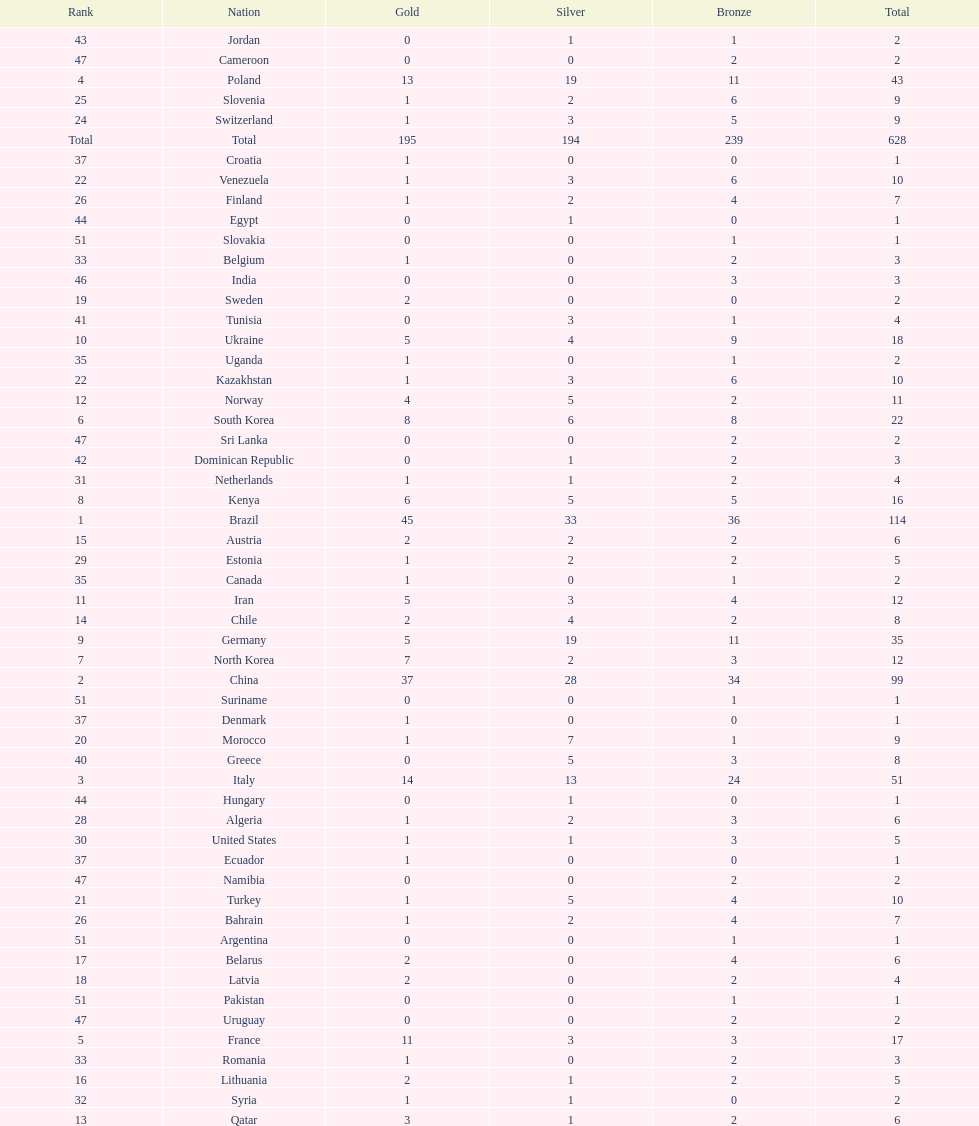South korea has how many more medals that north korea? 10. 